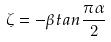<formula> <loc_0><loc_0><loc_500><loc_500>\zeta = - \beta t a n \frac { \pi \alpha } { 2 }</formula> 